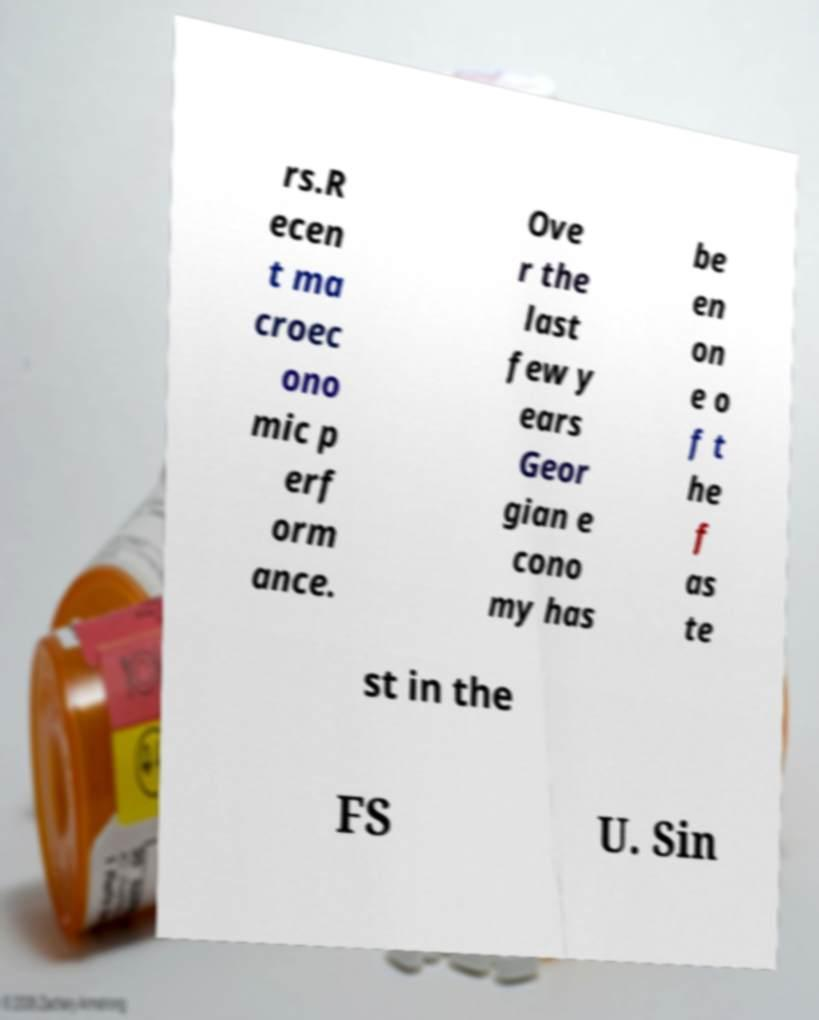Please identify and transcribe the text found in this image. rs.R ecen t ma croec ono mic p erf orm ance. Ove r the last few y ears Geor gian e cono my has be en on e o f t he f as te st in the FS U. Sin 